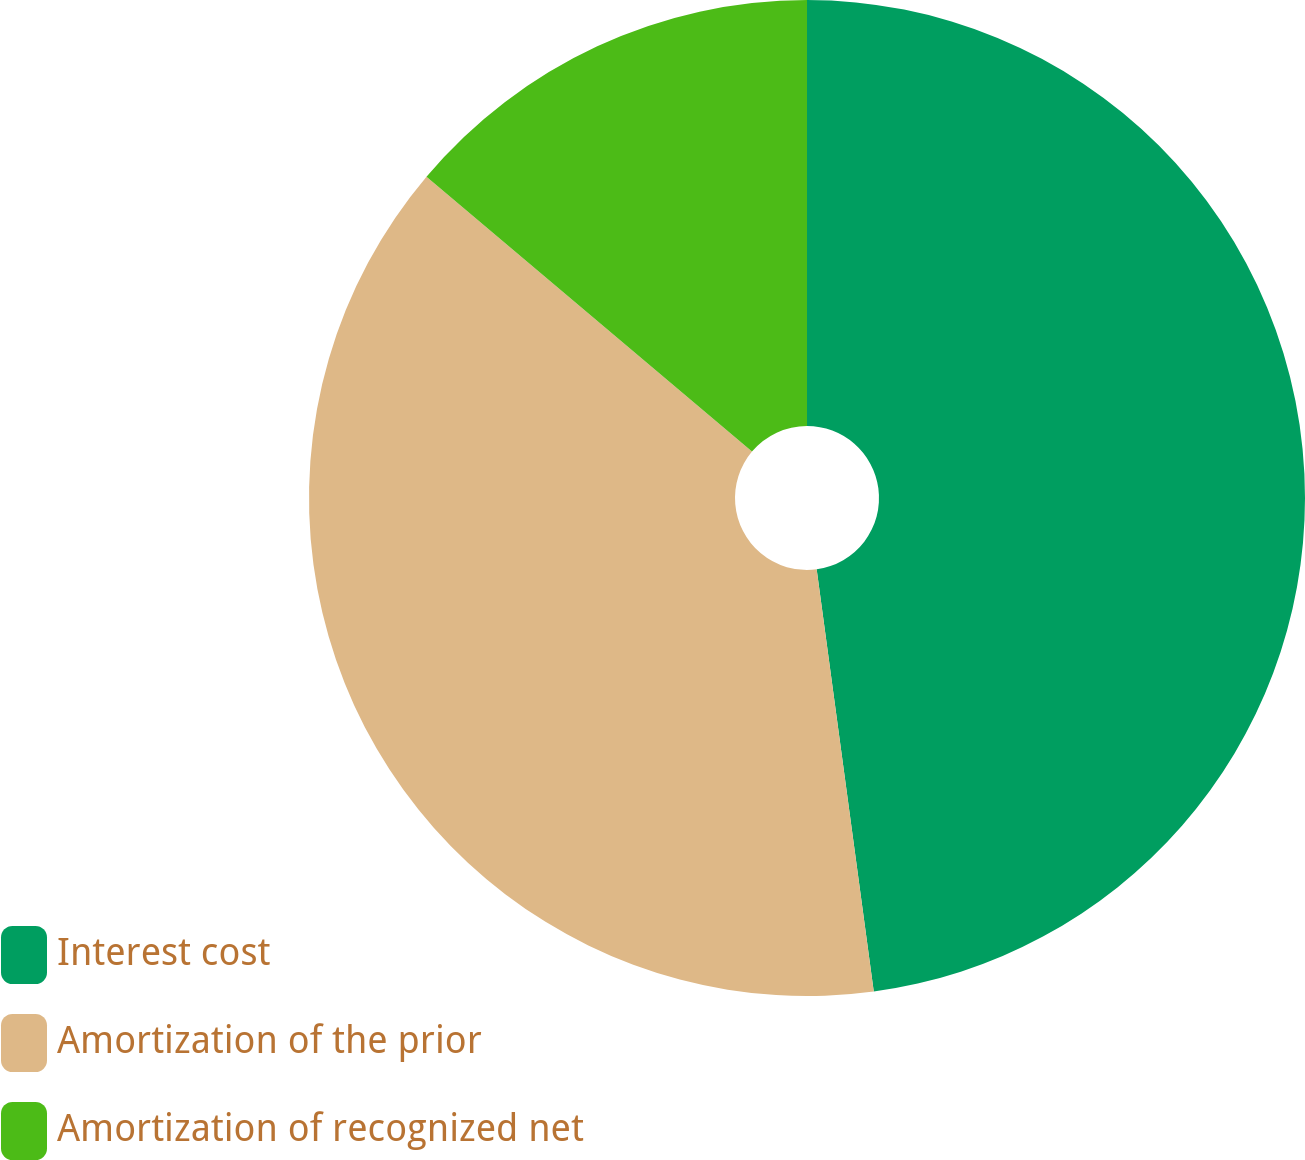Convert chart to OTSL. <chart><loc_0><loc_0><loc_500><loc_500><pie_chart><fcel>Interest cost<fcel>Amortization of the prior<fcel>Amortization of recognized net<nl><fcel>47.86%<fcel>38.3%<fcel>13.84%<nl></chart> 